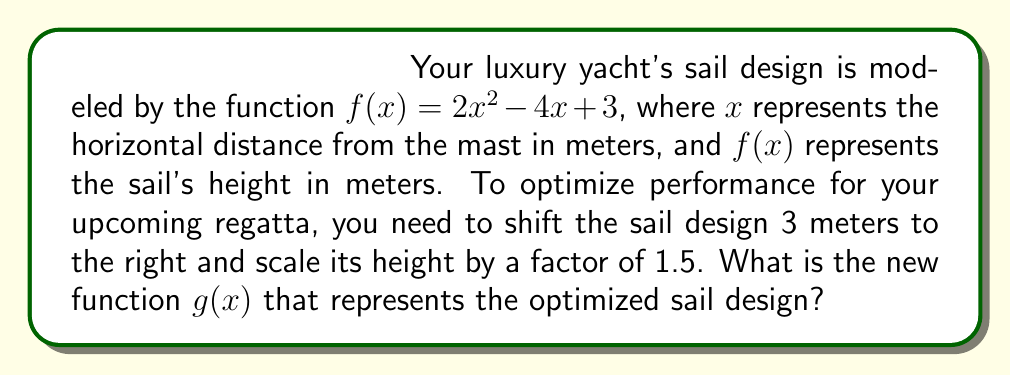Provide a solution to this math problem. Let's approach this step-by-step:

1) First, we need to shift the function 3 meters to the right. This is done by replacing every $x$ in the original function with $(x - 3)$:

   $f(x - 3) = 2(x - 3)^2 - 4(x - 3) + 3$

2) Now, let's expand this:
   
   $f(x - 3) = 2(x^2 - 6x + 9) - 4x + 12 + 3$
   $f(x - 3) = 2x^2 - 12x + 18 - 4x + 15$
   $f(x - 3) = 2x^2 - 16x + 33$

3) Next, we need to scale the height by a factor of 1.5. This means multiplying the entire function by 1.5:

   $g(x) = 1.5(2x^2 - 16x + 33)$

4) Let's simplify this:

   $g(x) = 3x^2 - 24x + 49.5$

This is our final optimized sail design function.
Answer: $g(x) = 3x^2 - 24x + 49.5$ 